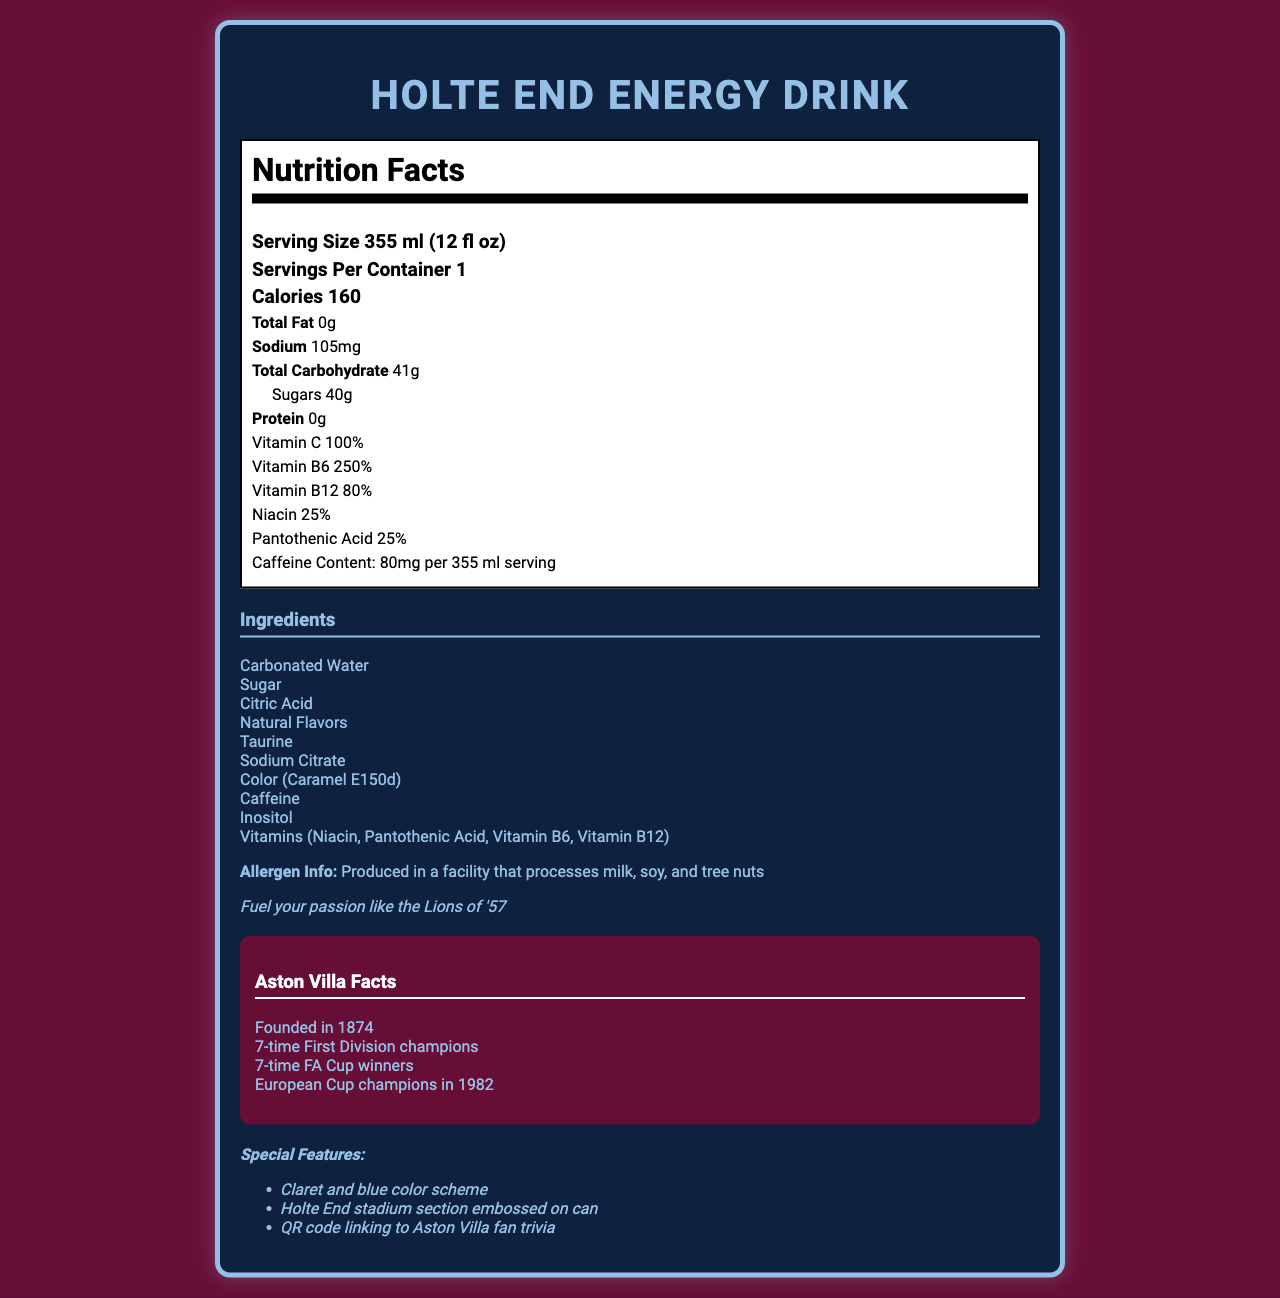What is the serving size of the Holte End Energy Drink? The serving size is clearly stated in the nutrition label section of the document.
Answer: 355 ml (12 fl oz) How many calories are in one serving of the Holte End Energy Drink? The number of calories per serving is stated in the nutrition label section.
Answer: 160 What is the amount of sodium in one serving? The sodium content is provided in the nutrition label section.
Answer: 105 mg Which vitamins are present in the Holte End Energy Drink, and what are their percentages? The vitamins and their percentages are listed in the nutrition label section.
Answer: Vitamin C: 100%, Vitamin B6: 250%, Vitamin B12: 80%, Niacin: 25%, Pantothenic Acid: 25% What is the product tagline for the Holte End Energy Drink? The product tagline is provided under the allergen info section.
Answer: Fuel your passion like the Lions of '57 Which section of the stadium is embossed on the can of the Holte End Energy Drink? The special features section states that the Holte End stadium section is embossed on the can.
Answer: Holte End stadium section How much caffeine is in one serving of the Holte End Energy Drink? The caffeine content is specified in the nutrition label section.
Answer: 80 mg per 355 ml serving What are the special features of the Holte End Energy Drink can? 1. Claret and blue color scheme 2. Holte End stadium section embossed on can 3. QR code linking to Aston Villa fan trivia The special features are listed in the special features section of the document.
Answer: 1, 2, 3 Which of the following ingredients is NOT found in the Holte End Energy Drink? A. Sugar B. Citric Acid C. High Fructose Corn Syrup D. Caffeine The ingredients list does not include High Fructose Corn Syrup.
Answer: C. High Fructose Corn Syrup What year did Aston Villa win the European Cup? A. 1980 B. 1982 C. 1984 D. 1986 The facts section states that Aston Villa won the European Cup in 1982.
Answer: B. 1982 Is the Holte End Energy Drink produced in a facility that processes tree nuts? The allergen info states that the drink is produced in a facility that processes milk, soy, and tree nuts.
Answer: Yes Describe the main idea of the document. The document thoroughly covers the nutritional breakdown, special features, and Aston Villa-related attributes of the Holte End Energy Drink, presenting a comprehensive insight into the product.
Answer: The document provides a detailed overview of the Holte End Energy Drink, including its nutritional facts, ingredients, allergen information, special features, and a vintage photo description of the 1957 FA Cup winning Aston Villa team. Additionally, it includes some interesting facts about Aston Villa Football Club. Who was featured in the 1957 FA Cup winning Aston Villa team photo on the can? The vintage photo description states it features Peter McParland and Johnny Dixon.
Answer: Peter McParland and Johnny Dixon What is the total carbohydrate content for one serving of the Holte End Energy Drink? The total carbohydrate content is indicated in the nutrition label section.
Answer: 41 g What is the total protein content in the Holte End Energy Drink? The protein content is stated in the nutrition label section.
Answer: 0 g What are the claret and blue colors significant to? The special features section mentions that the claret and blue color scheme is significant, referring to Aston Villa's traditional colors.
Answer: Aston Villa Football Club's traditional colors 